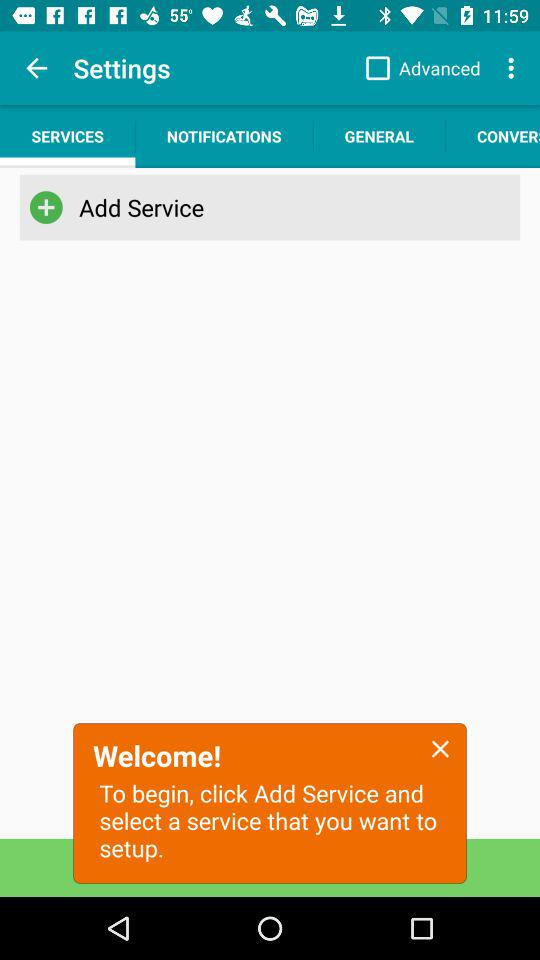What is the status of "Advanced"? The status is "off". 